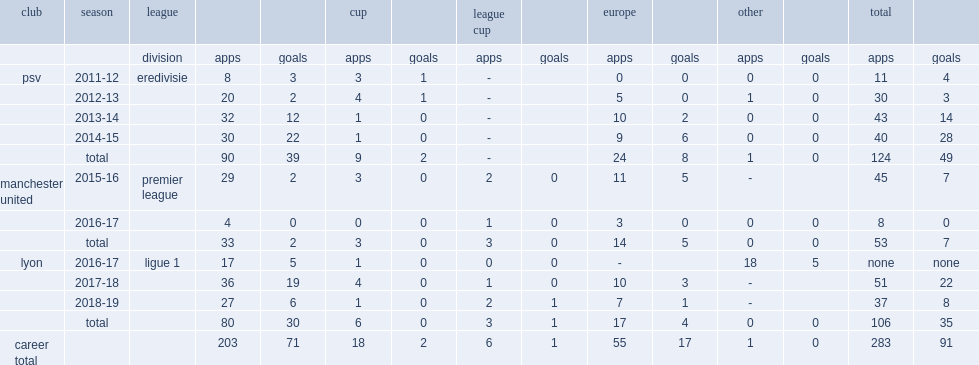What was the number of appearances made by depay for psv? 124.0. 